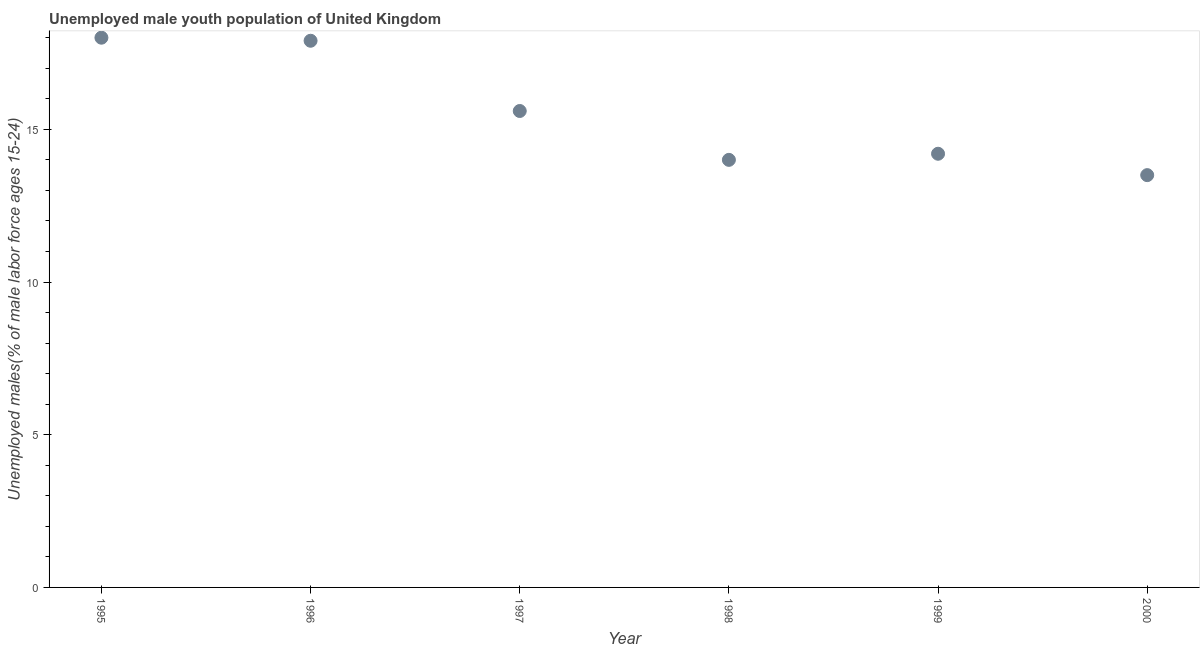What is the unemployed male youth in 1999?
Give a very brief answer. 14.2. What is the sum of the unemployed male youth?
Provide a short and direct response. 93.2. What is the difference between the unemployed male youth in 1998 and 1999?
Provide a short and direct response. -0.2. What is the average unemployed male youth per year?
Offer a very short reply. 15.53. What is the median unemployed male youth?
Your answer should be compact. 14.9. Do a majority of the years between 1999 and 1998 (inclusive) have unemployed male youth greater than 10 %?
Your answer should be very brief. No. What is the ratio of the unemployed male youth in 1999 to that in 2000?
Your answer should be compact. 1.05. Is the unemployed male youth in 1997 less than that in 1998?
Offer a very short reply. No. Is the difference between the unemployed male youth in 1996 and 1999 greater than the difference between any two years?
Offer a very short reply. No. What is the difference between the highest and the second highest unemployed male youth?
Offer a terse response. 0.1. In how many years, is the unemployed male youth greater than the average unemployed male youth taken over all years?
Offer a terse response. 3. How many years are there in the graph?
Keep it short and to the point. 6. What is the difference between two consecutive major ticks on the Y-axis?
Offer a very short reply. 5. Are the values on the major ticks of Y-axis written in scientific E-notation?
Your answer should be compact. No. Does the graph contain any zero values?
Make the answer very short. No. What is the title of the graph?
Ensure brevity in your answer.  Unemployed male youth population of United Kingdom. What is the label or title of the Y-axis?
Provide a succinct answer. Unemployed males(% of male labor force ages 15-24). What is the Unemployed males(% of male labor force ages 15-24) in 1995?
Offer a terse response. 18. What is the Unemployed males(% of male labor force ages 15-24) in 1996?
Your response must be concise. 17.9. What is the Unemployed males(% of male labor force ages 15-24) in 1997?
Ensure brevity in your answer.  15.6. What is the Unemployed males(% of male labor force ages 15-24) in 1999?
Your response must be concise. 14.2. What is the Unemployed males(% of male labor force ages 15-24) in 2000?
Offer a terse response. 13.5. What is the difference between the Unemployed males(% of male labor force ages 15-24) in 1995 and 1996?
Your answer should be very brief. 0.1. What is the difference between the Unemployed males(% of male labor force ages 15-24) in 1995 and 1997?
Provide a short and direct response. 2.4. What is the difference between the Unemployed males(% of male labor force ages 15-24) in 1995 and 1998?
Provide a short and direct response. 4. What is the difference between the Unemployed males(% of male labor force ages 15-24) in 1995 and 2000?
Your answer should be very brief. 4.5. What is the difference between the Unemployed males(% of male labor force ages 15-24) in 1996 and 1997?
Give a very brief answer. 2.3. What is the difference between the Unemployed males(% of male labor force ages 15-24) in 1996 and 1999?
Make the answer very short. 3.7. What is the difference between the Unemployed males(% of male labor force ages 15-24) in 1997 and 1998?
Make the answer very short. 1.6. What is the difference between the Unemployed males(% of male labor force ages 15-24) in 1997 and 2000?
Keep it short and to the point. 2.1. What is the difference between the Unemployed males(% of male labor force ages 15-24) in 1998 and 1999?
Your answer should be very brief. -0.2. What is the difference between the Unemployed males(% of male labor force ages 15-24) in 1998 and 2000?
Give a very brief answer. 0.5. What is the difference between the Unemployed males(% of male labor force ages 15-24) in 1999 and 2000?
Give a very brief answer. 0.7. What is the ratio of the Unemployed males(% of male labor force ages 15-24) in 1995 to that in 1996?
Make the answer very short. 1.01. What is the ratio of the Unemployed males(% of male labor force ages 15-24) in 1995 to that in 1997?
Offer a very short reply. 1.15. What is the ratio of the Unemployed males(% of male labor force ages 15-24) in 1995 to that in 1998?
Your answer should be very brief. 1.29. What is the ratio of the Unemployed males(% of male labor force ages 15-24) in 1995 to that in 1999?
Keep it short and to the point. 1.27. What is the ratio of the Unemployed males(% of male labor force ages 15-24) in 1995 to that in 2000?
Provide a succinct answer. 1.33. What is the ratio of the Unemployed males(% of male labor force ages 15-24) in 1996 to that in 1997?
Offer a terse response. 1.15. What is the ratio of the Unemployed males(% of male labor force ages 15-24) in 1996 to that in 1998?
Offer a terse response. 1.28. What is the ratio of the Unemployed males(% of male labor force ages 15-24) in 1996 to that in 1999?
Your answer should be compact. 1.26. What is the ratio of the Unemployed males(% of male labor force ages 15-24) in 1996 to that in 2000?
Make the answer very short. 1.33. What is the ratio of the Unemployed males(% of male labor force ages 15-24) in 1997 to that in 1998?
Give a very brief answer. 1.11. What is the ratio of the Unemployed males(% of male labor force ages 15-24) in 1997 to that in 1999?
Provide a short and direct response. 1.1. What is the ratio of the Unemployed males(% of male labor force ages 15-24) in 1997 to that in 2000?
Provide a succinct answer. 1.16. What is the ratio of the Unemployed males(% of male labor force ages 15-24) in 1998 to that in 1999?
Offer a terse response. 0.99. What is the ratio of the Unemployed males(% of male labor force ages 15-24) in 1998 to that in 2000?
Your response must be concise. 1.04. What is the ratio of the Unemployed males(% of male labor force ages 15-24) in 1999 to that in 2000?
Your answer should be very brief. 1.05. 